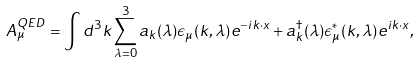Convert formula to latex. <formula><loc_0><loc_0><loc_500><loc_500>A _ { \mu } ^ { Q E D } = \int d ^ { 3 } k \sum _ { \lambda = 0 } ^ { 3 } a _ { k } ( \lambda ) \epsilon _ { \mu } ( k , \lambda ) e ^ { - i k \cdot x } + a _ { k } ^ { \dagger } ( \lambda ) \epsilon _ { \mu } ^ { \ast } ( k , \lambda ) e ^ { i k \cdot x } ,</formula> 